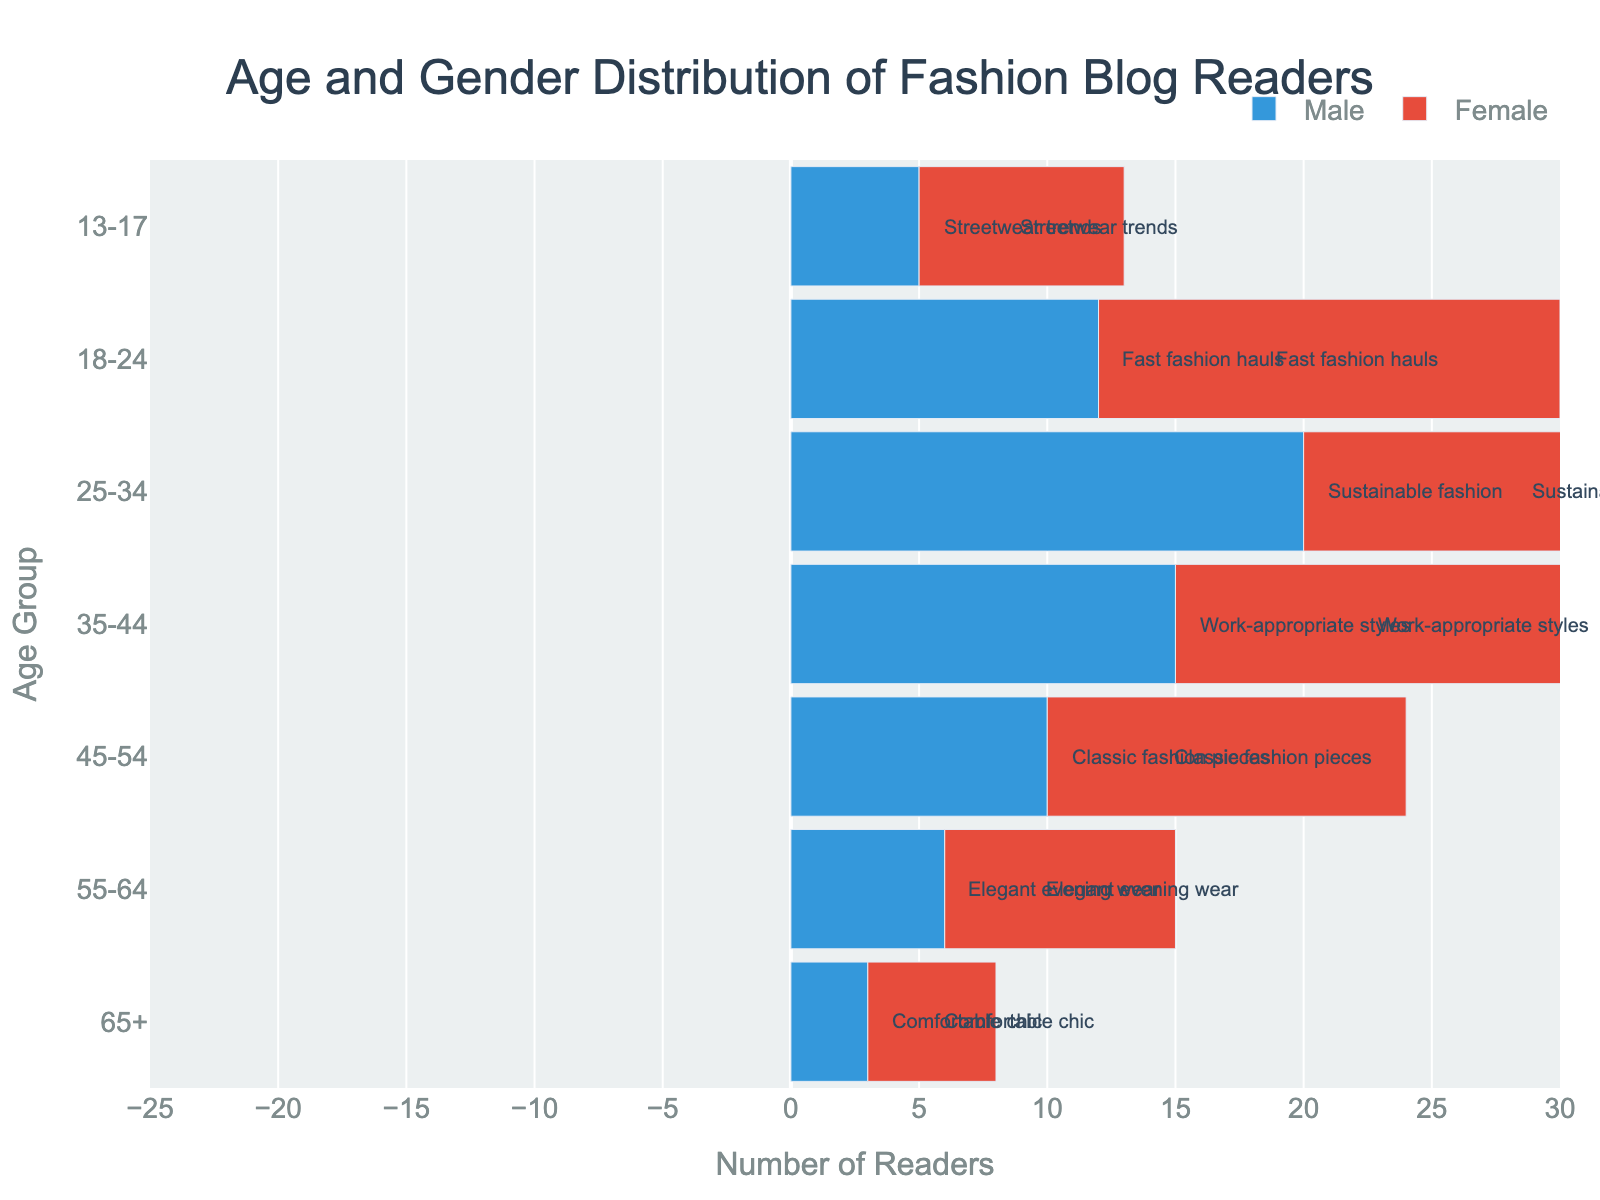What's the title of the figure? The title is displayed prominently at the top of the figure. It reads 'Age and Gender Distribution of Fashion Blog Readers'.
Answer: Age and Gender Distribution of Fashion Blog Readers What age group has the highest number of female readers? To determine this, look at the longest bar extending to the right (positive side), which represents the number of female readers. The 25-34 age group has the longest female bar.
Answer: 25-34 Which age group has an equal number of male and female readers? Check for age groups where the absolute values of the male and female bars are equal in length. In this figure, there is no age group with equal numbers of male and female readers.
Answer: None What's the most preferred content type for the 25-34 age group? Check the annotation present at the corresponding bars for the age group 25-34. It shows 'Sustainable fashion' as the preferred content type.
Answer: Sustainable fashion Compare the number of male and female readers in the 18-24 age group. Examine the lengths of the bars for males and females in this group. The male value is -12, and the female value is 18. The number of female readers is 30 more than the male readers.
Answer: 18 more Which age group has the smallest total readership? Calculate the absolute sum of male and female readers for each age group and find the minimum. For the 65+ age group, the total is
Answer: 8 What is the preferred content of fashion readers aged between 35-44 years? Observe the annotation present near the bars for the age group 35-44. It shows 'Work-appropriate styles' as the preferred content.
Answer: Work-appropriate styles In the 45-54 age group, do male readers prefer the same content as female readers? Refer to the annotation for 45-54 age group, which indicates 'Classic fashion pieces' for both genders.
Answer: Yes Which gender has more readers in the 'Comfortable chic' content category? Refer to the annotations and their corresponding bars. 'Comfortable chic' is preferred by the 65+ age group: males (3) vs. females (5).
Answer: Female From which age group does most male readers prefer "Elegant evening wear"? Check for the age group annotations indicating 'Elegant evening wear'. It pertains to 55-64 years with 9 females and 6 males preferring it.
Answer: 55-64 